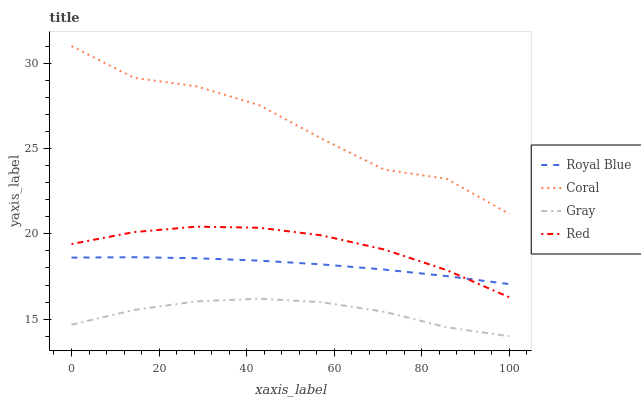Does Gray have the minimum area under the curve?
Answer yes or no. Yes. Does Coral have the maximum area under the curve?
Answer yes or no. Yes. Does Red have the minimum area under the curve?
Answer yes or no. No. Does Red have the maximum area under the curve?
Answer yes or no. No. Is Royal Blue the smoothest?
Answer yes or no. Yes. Is Coral the roughest?
Answer yes or no. Yes. Is Red the smoothest?
Answer yes or no. No. Is Red the roughest?
Answer yes or no. No. Does Gray have the lowest value?
Answer yes or no. Yes. Does Red have the lowest value?
Answer yes or no. No. Does Coral have the highest value?
Answer yes or no. Yes. Does Red have the highest value?
Answer yes or no. No. Is Gray less than Coral?
Answer yes or no. Yes. Is Coral greater than Gray?
Answer yes or no. Yes. Does Red intersect Royal Blue?
Answer yes or no. Yes. Is Red less than Royal Blue?
Answer yes or no. No. Is Red greater than Royal Blue?
Answer yes or no. No. Does Gray intersect Coral?
Answer yes or no. No. 